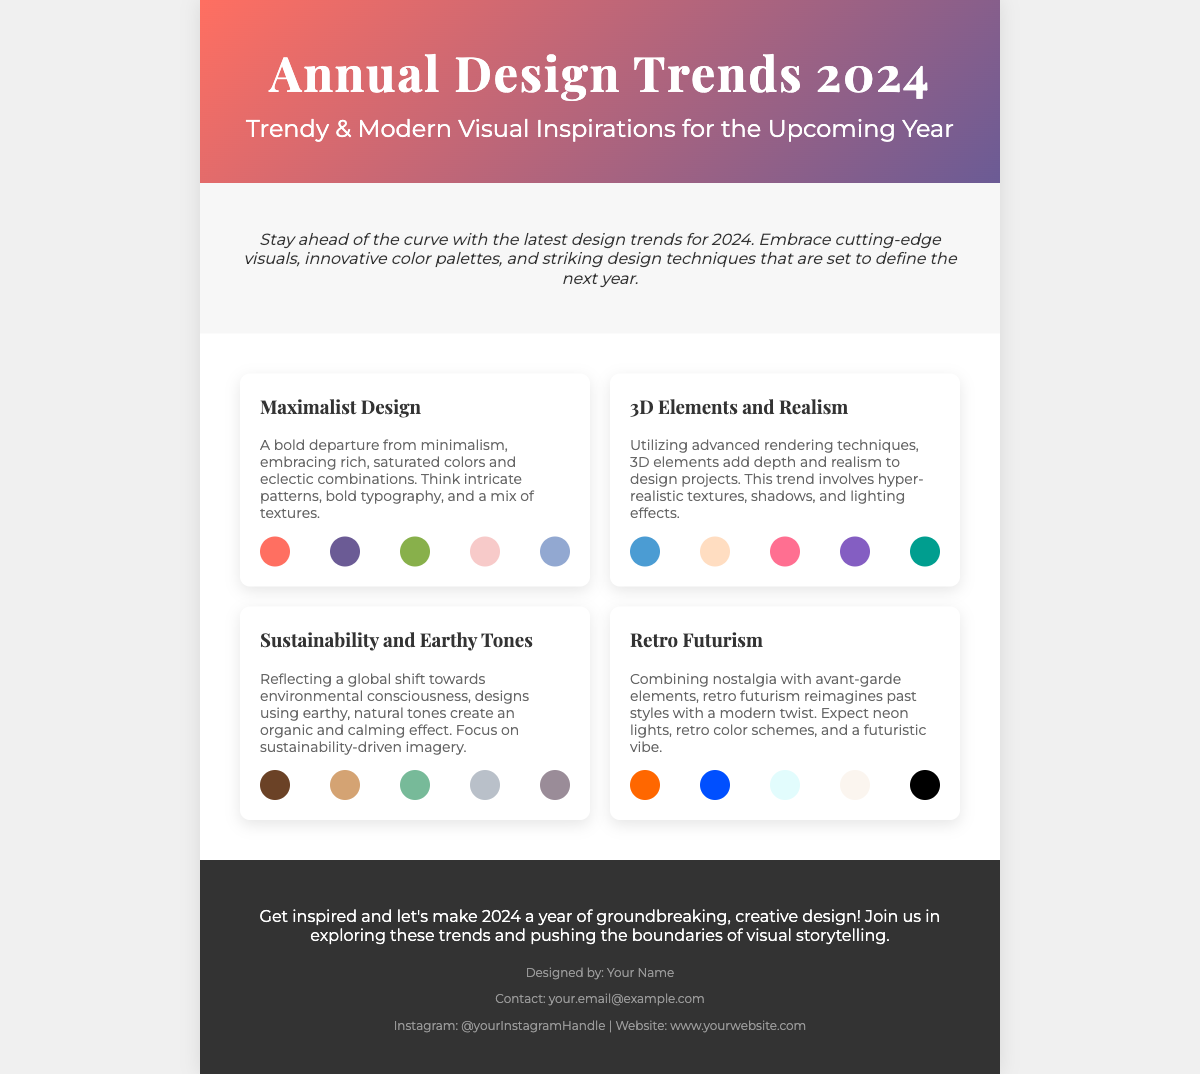What is the title of the poster? The title is prominently displayed at the top of the poster.
Answer: Annual Design Trends 2024 How many trends are showcased in the poster? Each trend is presented clearly in separate sections, which can be counted.
Answer: Four What is the color palette for Maximalist Design? The palette consists of five color swatches displayed under the trend section.
Answer: #FF6F61, #6B5B95, #88B04B, #F7CAC9, #92A8D1 Which design trend emphasizes environmental consciousness? The trend specifically addressing this theme is titled distinctly in the content.
Answer: Sustainability and Earthy Tones What is the main font used in the poster? The font style is defined within the CSS of the document.
Answer: Montserrat What type of visuals are highlighted for 3D Elements and Realism? This trend describes specific attributes regarding visuals and techniques applied in design.
Answer: Hyper-realistic textures What method enhances the Retro Futurism trend? The focus of this trend indicates specific stylistic elements associated with it.
Answer: Nostalgia What is the purpose of the introduction section? The introduction sets the context and importance of the trends showcased in the poster.
Answer: Stay ahead of the curve What is the color scheme used in the header? The gradient colors in the header are specified in the design section.
Answer: #FF6F61, #6B5B95 